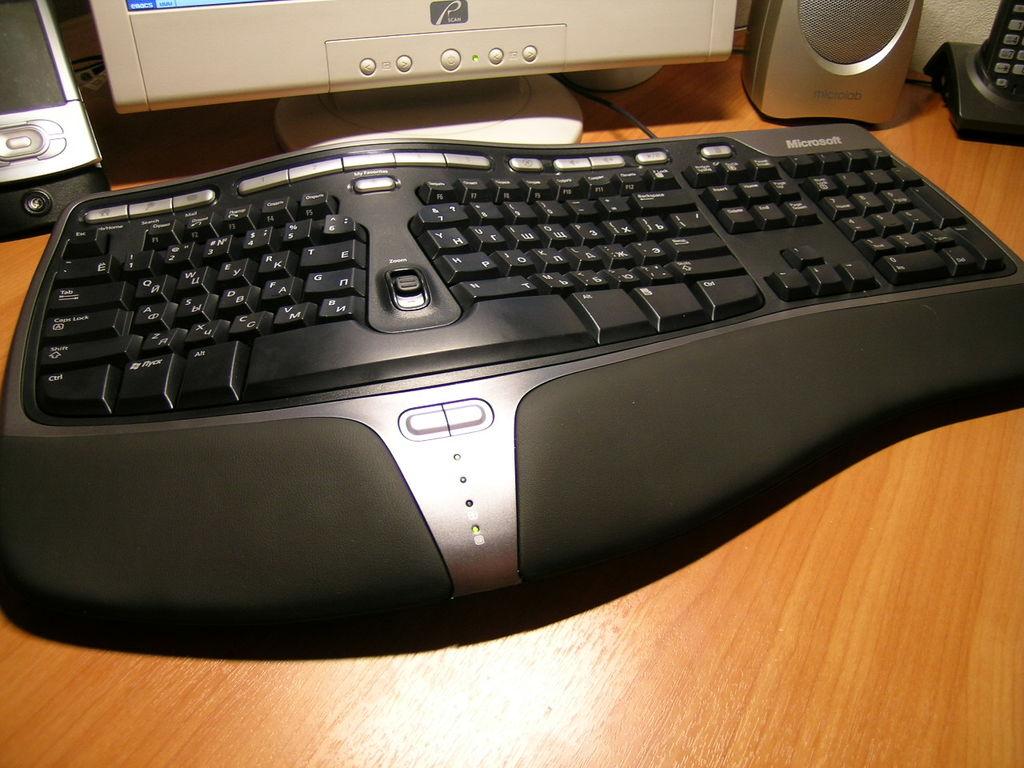What company manufactured this keyboard?
Keep it short and to the point. Microsoft. What is the brand of speakers?
Give a very brief answer. Microlab. 